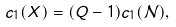<formula> <loc_0><loc_0><loc_500><loc_500>c _ { 1 } ( X ) = ( Q - 1 ) c _ { 1 } ( { \mathcal { N } } ) ,</formula> 